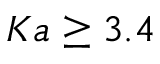Convert formula to latex. <formula><loc_0><loc_0><loc_500><loc_500>K a \geq 3 . 4</formula> 